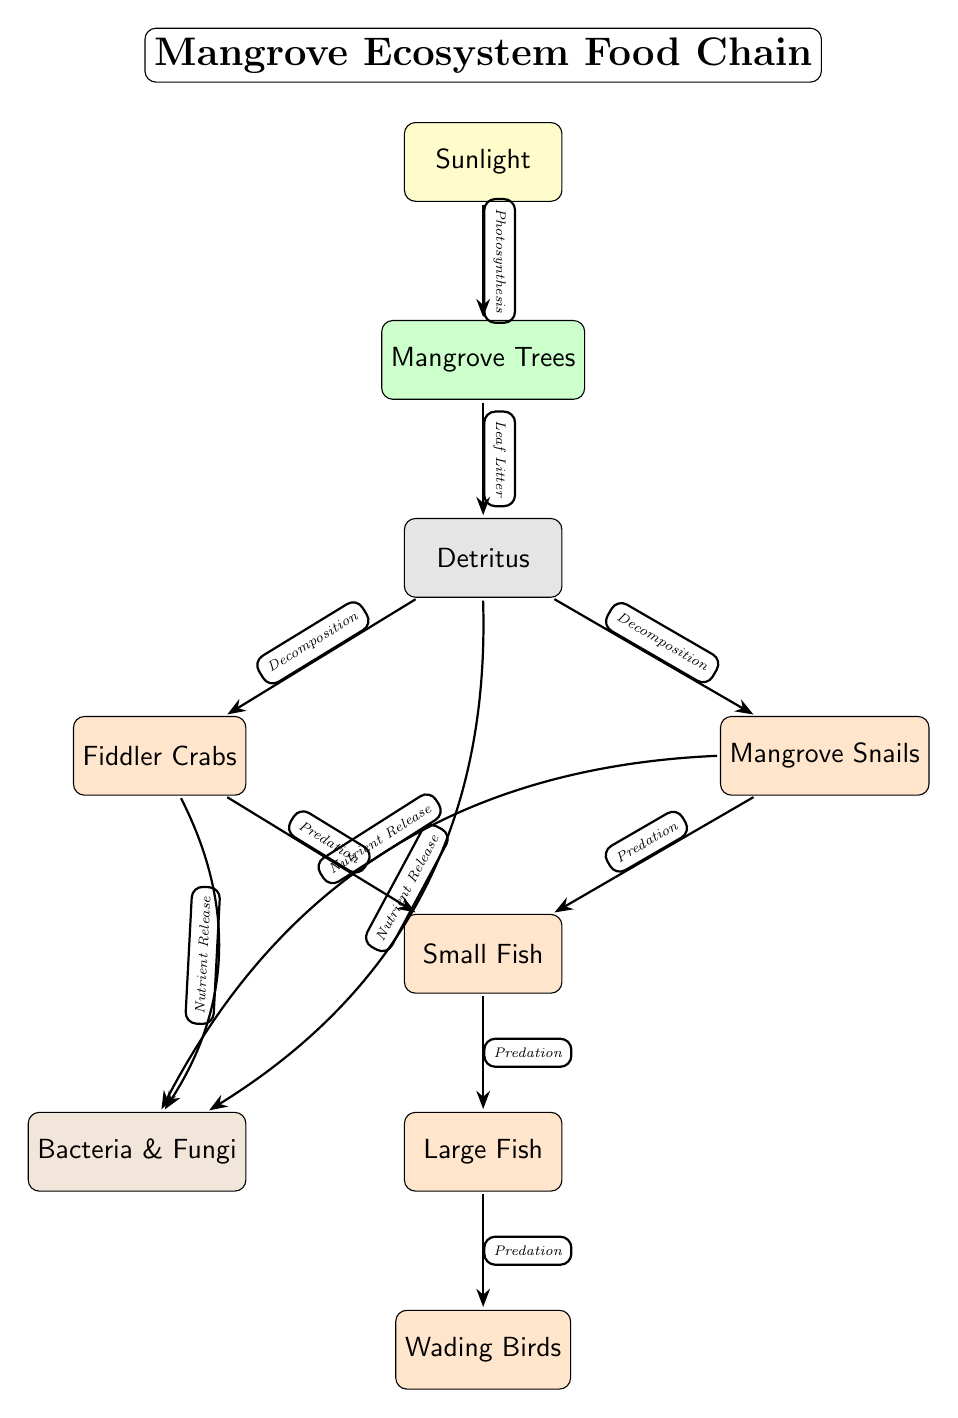What is at the top of the diagram? The topmost node in the diagram is sunlight, which is indicated as the primary energy source in the food chain.
Answer: Sunlight How many consumer nodes are present in the diagram? By counting the nodes labeled as consumers (Fiddler Crabs, Mangrove Snails, Small Fish, Large Fish, and Wading Birds), there are a total of five consumer nodes.
Answer: 5 What do mangrove trees produce through photosynthesis? According to the diagram, mangrove trees use sunlight to perform photosynthesis and produce energy, establishing their role as producers in the ecosystem.
Answer: Energy Which organisms are the primary consumers in this food chain? The primary consumers in this food chain are the Fiddler Crabs and Mangrove Snails, which feed on detritus.
Answer: Fiddler Crabs and Mangrove Snails What process involves detritus breaking down into nutrients? The process described in the diagram that involves detritus breaking down into nutrients is called decomposition, which occurs through the action of decomposers like bacteria and fungi.
Answer: Decomposition How do Fiddler Crabs contribute to nutrient cycling? Fiddler Crabs release nutrients back into the ecosystem when they feed on detritus, which is shown in the diagram as part of nutrient cycling connected to decomposers.
Answer: Nutrient Release Which consumer feeds on both Fiddler Crabs and Mangrove Snails? The Small Fish is the consumer that preys on both Fiddler Crabs and Mangrove Snails according to the connections illustrated in the diagram.
Answer: Small Fish What happens to large fish in the food chain? In the food chain as depicted, large fish serve as predators that feed on smaller fish and, in turn, are preyed upon by Wading Birds, demonstrating their role in the ecosystem.
Answer: Predation How do decomposers fit into the nutrient cycling process? Decomposers, represented by bacteria and fungi in the diagram, play a crucial role in breaking down detritus and organisms, returning nutrients back to the ecosystem, thereby completing the nutrient cycling process.
Answer: Nutrient Cycling 